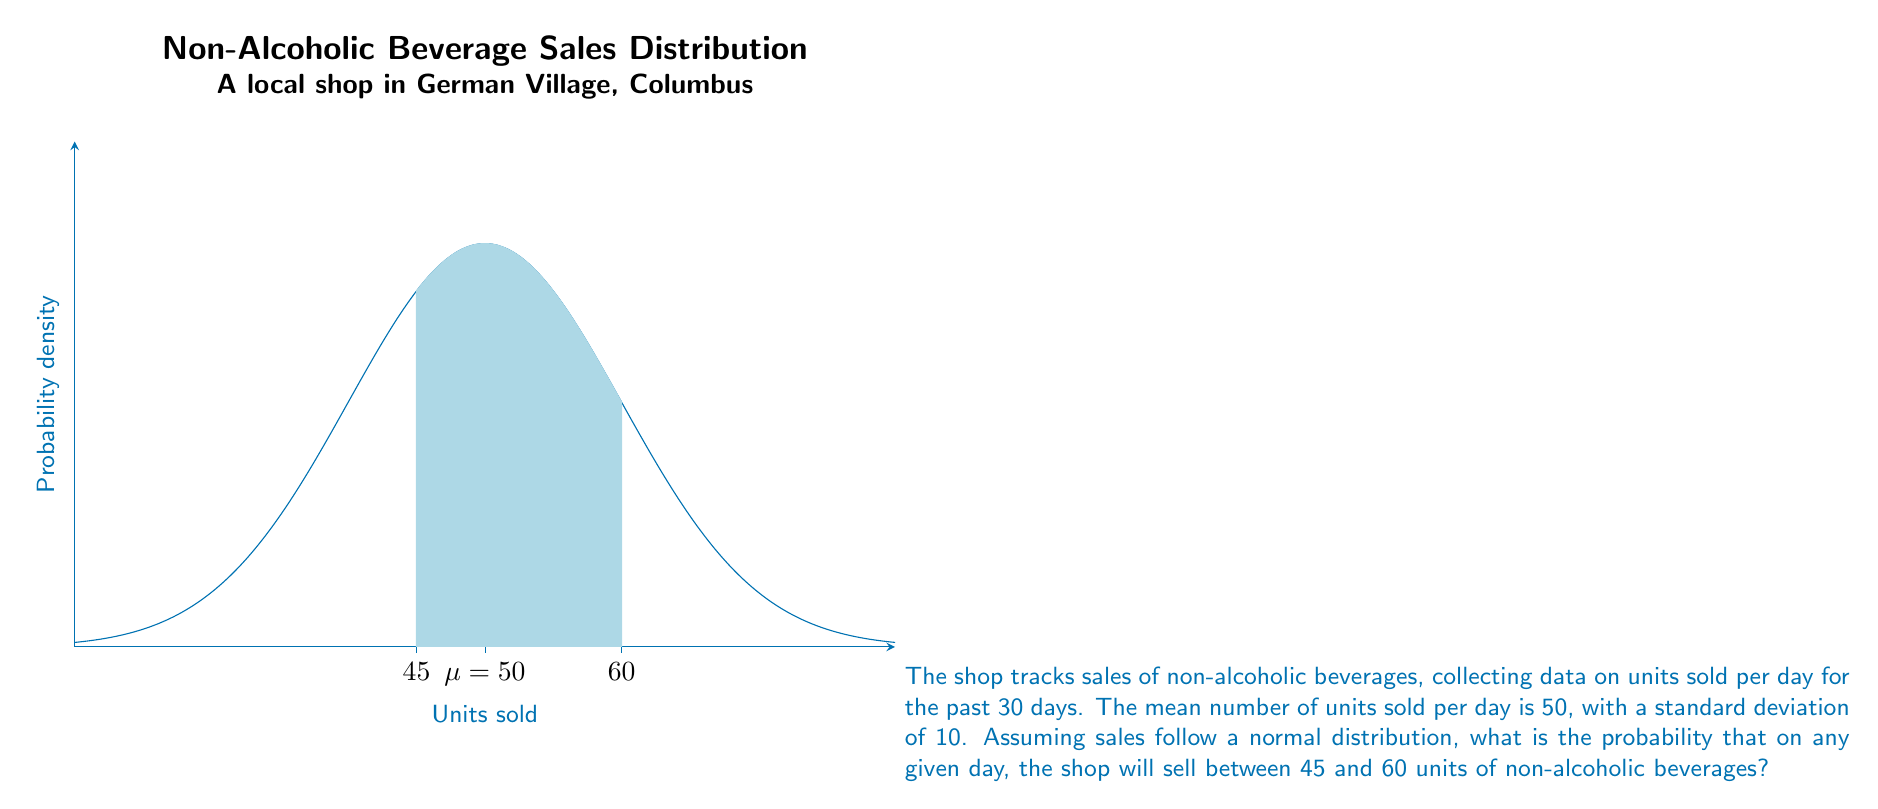Can you answer this question? To solve this problem, we'll use the properties of the normal distribution and the concept of z-scores. Here's a step-by-step explanation:

1) We're given that the distribution is normal with a mean (μ) of 50 and a standard deviation (σ) of 10.

2) We need to find P(45 < X < 60), where X is the number of units sold per day.

3) To use the standard normal distribution table, we need to convert these values to z-scores:

   For 45 units: $z_1 = \frac{45 - 50}{10} = -0.5$
   For 60 units: $z_2 = \frac{60 - 50}{10} = 1$

4) Now, we need to find P(-0.5 < Z < 1), where Z is the standard normal variable.

5) Using a standard normal distribution table or calculator:
   P(Z < 1) = 0.8413
   P(Z < -0.5) = 0.3085

6) The probability we're looking for is:
   P(-0.5 < Z < 1) = P(Z < 1) - P(Z < -0.5)
                   = 0.8413 - 0.3085
                   = 0.5328

7) Therefore, the probability that the shop will sell between 45 and 60 units of non-alcoholic beverages on any given day is approximately 0.5328 or 53.28%.
Answer: 0.5328 or 53.28% 